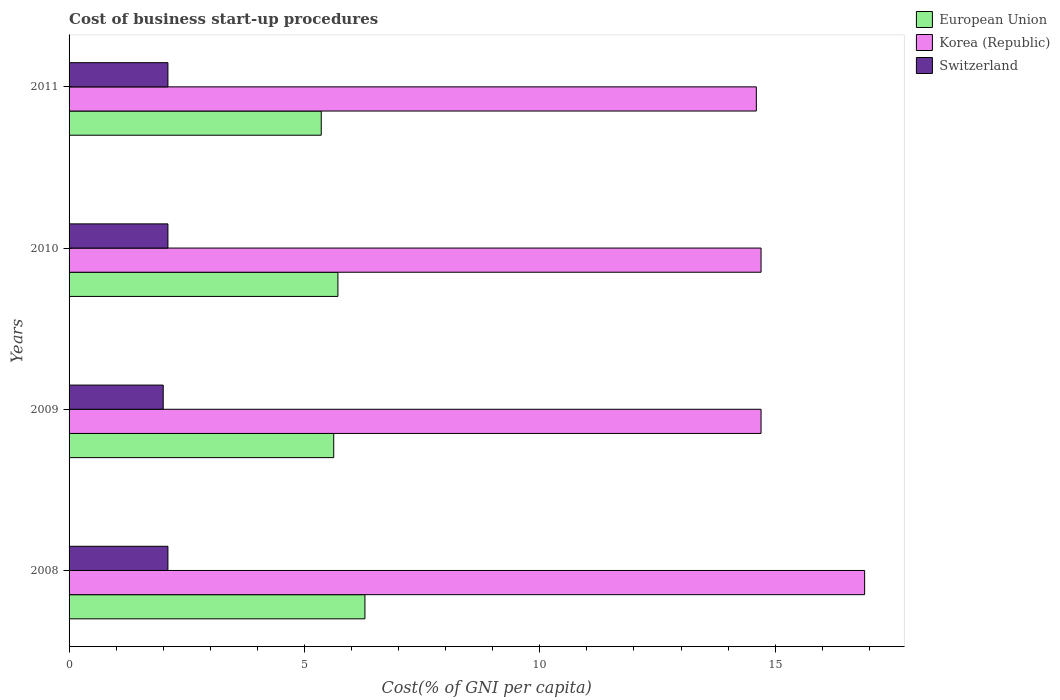How many groups of bars are there?
Your answer should be compact. 4. Are the number of bars per tick equal to the number of legend labels?
Make the answer very short. Yes. How many bars are there on the 3rd tick from the top?
Offer a terse response. 3. How many bars are there on the 4th tick from the bottom?
Offer a terse response. 3. What is the label of the 3rd group of bars from the top?
Your response must be concise. 2009. In how many cases, is the number of bars for a given year not equal to the number of legend labels?
Keep it short and to the point. 0. What is the cost of business start-up procedures in Korea (Republic) in 2008?
Your response must be concise. 16.9. Across all years, what is the minimum cost of business start-up procedures in European Union?
Offer a terse response. 5.36. What is the total cost of business start-up procedures in European Union in the graph?
Offer a very short reply. 22.98. What is the difference between the cost of business start-up procedures in European Union in 2008 and that in 2011?
Provide a short and direct response. 0.93. What is the difference between the cost of business start-up procedures in European Union in 2011 and the cost of business start-up procedures in Korea (Republic) in 2008?
Your answer should be compact. -11.54. What is the average cost of business start-up procedures in Korea (Republic) per year?
Offer a terse response. 15.22. In the year 2011, what is the difference between the cost of business start-up procedures in European Union and cost of business start-up procedures in Korea (Republic)?
Provide a short and direct response. -9.24. What is the ratio of the cost of business start-up procedures in Switzerland in 2009 to that in 2010?
Offer a very short reply. 0.95. Is the cost of business start-up procedures in Switzerland in 2008 less than that in 2010?
Your answer should be very brief. No. Is the difference between the cost of business start-up procedures in European Union in 2008 and 2010 greater than the difference between the cost of business start-up procedures in Korea (Republic) in 2008 and 2010?
Your answer should be very brief. No. What is the difference between the highest and the second highest cost of business start-up procedures in Korea (Republic)?
Provide a short and direct response. 2.2. What is the difference between the highest and the lowest cost of business start-up procedures in Switzerland?
Offer a very short reply. 0.1. In how many years, is the cost of business start-up procedures in Korea (Republic) greater than the average cost of business start-up procedures in Korea (Republic) taken over all years?
Make the answer very short. 1. Is the sum of the cost of business start-up procedures in European Union in 2008 and 2011 greater than the maximum cost of business start-up procedures in Switzerland across all years?
Ensure brevity in your answer.  Yes. What does the 2nd bar from the bottom in 2011 represents?
Ensure brevity in your answer.  Korea (Republic). What is the difference between two consecutive major ticks on the X-axis?
Ensure brevity in your answer.  5. Does the graph contain any zero values?
Your answer should be very brief. No. How many legend labels are there?
Keep it short and to the point. 3. How are the legend labels stacked?
Offer a terse response. Vertical. What is the title of the graph?
Keep it short and to the point. Cost of business start-up procedures. Does "Brazil" appear as one of the legend labels in the graph?
Your answer should be very brief. No. What is the label or title of the X-axis?
Offer a terse response. Cost(% of GNI per capita). What is the Cost(% of GNI per capita) in European Union in 2008?
Give a very brief answer. 6.29. What is the Cost(% of GNI per capita) in Korea (Republic) in 2008?
Your answer should be very brief. 16.9. What is the Cost(% of GNI per capita) in European Union in 2009?
Offer a very short reply. 5.62. What is the Cost(% of GNI per capita) in Korea (Republic) in 2009?
Provide a succinct answer. 14.7. What is the Cost(% of GNI per capita) of European Union in 2010?
Your response must be concise. 5.71. What is the Cost(% of GNI per capita) in Switzerland in 2010?
Your response must be concise. 2.1. What is the Cost(% of GNI per capita) of European Union in 2011?
Keep it short and to the point. 5.36. What is the Cost(% of GNI per capita) of Korea (Republic) in 2011?
Your answer should be very brief. 14.6. What is the Cost(% of GNI per capita) in Switzerland in 2011?
Provide a succinct answer. 2.1. Across all years, what is the maximum Cost(% of GNI per capita) of European Union?
Your response must be concise. 6.29. Across all years, what is the maximum Cost(% of GNI per capita) in Korea (Republic)?
Keep it short and to the point. 16.9. Across all years, what is the maximum Cost(% of GNI per capita) of Switzerland?
Your answer should be very brief. 2.1. Across all years, what is the minimum Cost(% of GNI per capita) in European Union?
Keep it short and to the point. 5.36. Across all years, what is the minimum Cost(% of GNI per capita) in Switzerland?
Keep it short and to the point. 2. What is the total Cost(% of GNI per capita) of European Union in the graph?
Your answer should be very brief. 22.98. What is the total Cost(% of GNI per capita) of Korea (Republic) in the graph?
Give a very brief answer. 60.9. What is the total Cost(% of GNI per capita) of Switzerland in the graph?
Ensure brevity in your answer.  8.3. What is the difference between the Cost(% of GNI per capita) in European Union in 2008 and that in 2009?
Provide a succinct answer. 0.66. What is the difference between the Cost(% of GNI per capita) of Korea (Republic) in 2008 and that in 2009?
Offer a terse response. 2.2. What is the difference between the Cost(% of GNI per capita) of Switzerland in 2008 and that in 2009?
Offer a terse response. 0.1. What is the difference between the Cost(% of GNI per capita) of European Union in 2008 and that in 2010?
Your response must be concise. 0.57. What is the difference between the Cost(% of GNI per capita) in European Union in 2008 and that in 2011?
Keep it short and to the point. 0.93. What is the difference between the Cost(% of GNI per capita) of Korea (Republic) in 2008 and that in 2011?
Offer a very short reply. 2.3. What is the difference between the Cost(% of GNI per capita) in European Union in 2009 and that in 2010?
Your response must be concise. -0.09. What is the difference between the Cost(% of GNI per capita) in Korea (Republic) in 2009 and that in 2010?
Offer a terse response. 0. What is the difference between the Cost(% of GNI per capita) of Switzerland in 2009 and that in 2010?
Provide a short and direct response. -0.1. What is the difference between the Cost(% of GNI per capita) of European Union in 2009 and that in 2011?
Keep it short and to the point. 0.27. What is the difference between the Cost(% of GNI per capita) of Korea (Republic) in 2009 and that in 2011?
Your answer should be very brief. 0.1. What is the difference between the Cost(% of GNI per capita) of European Union in 2010 and that in 2011?
Give a very brief answer. 0.35. What is the difference between the Cost(% of GNI per capita) in Switzerland in 2010 and that in 2011?
Keep it short and to the point. 0. What is the difference between the Cost(% of GNI per capita) of European Union in 2008 and the Cost(% of GNI per capita) of Korea (Republic) in 2009?
Offer a terse response. -8.41. What is the difference between the Cost(% of GNI per capita) of European Union in 2008 and the Cost(% of GNI per capita) of Switzerland in 2009?
Ensure brevity in your answer.  4.29. What is the difference between the Cost(% of GNI per capita) of European Union in 2008 and the Cost(% of GNI per capita) of Korea (Republic) in 2010?
Provide a short and direct response. -8.41. What is the difference between the Cost(% of GNI per capita) in European Union in 2008 and the Cost(% of GNI per capita) in Switzerland in 2010?
Provide a short and direct response. 4.19. What is the difference between the Cost(% of GNI per capita) in European Union in 2008 and the Cost(% of GNI per capita) in Korea (Republic) in 2011?
Provide a succinct answer. -8.31. What is the difference between the Cost(% of GNI per capita) in European Union in 2008 and the Cost(% of GNI per capita) in Switzerland in 2011?
Offer a terse response. 4.19. What is the difference between the Cost(% of GNI per capita) of European Union in 2009 and the Cost(% of GNI per capita) of Korea (Republic) in 2010?
Your answer should be compact. -9.08. What is the difference between the Cost(% of GNI per capita) of European Union in 2009 and the Cost(% of GNI per capita) of Switzerland in 2010?
Make the answer very short. 3.52. What is the difference between the Cost(% of GNI per capita) in European Union in 2009 and the Cost(% of GNI per capita) in Korea (Republic) in 2011?
Give a very brief answer. -8.98. What is the difference between the Cost(% of GNI per capita) in European Union in 2009 and the Cost(% of GNI per capita) in Switzerland in 2011?
Keep it short and to the point. 3.52. What is the difference between the Cost(% of GNI per capita) of Korea (Republic) in 2009 and the Cost(% of GNI per capita) of Switzerland in 2011?
Ensure brevity in your answer.  12.6. What is the difference between the Cost(% of GNI per capita) in European Union in 2010 and the Cost(% of GNI per capita) in Korea (Republic) in 2011?
Provide a succinct answer. -8.89. What is the difference between the Cost(% of GNI per capita) of European Union in 2010 and the Cost(% of GNI per capita) of Switzerland in 2011?
Keep it short and to the point. 3.61. What is the difference between the Cost(% of GNI per capita) of Korea (Republic) in 2010 and the Cost(% of GNI per capita) of Switzerland in 2011?
Provide a succinct answer. 12.6. What is the average Cost(% of GNI per capita) of European Union per year?
Make the answer very short. 5.74. What is the average Cost(% of GNI per capita) in Korea (Republic) per year?
Provide a succinct answer. 15.22. What is the average Cost(% of GNI per capita) in Switzerland per year?
Your response must be concise. 2.08. In the year 2008, what is the difference between the Cost(% of GNI per capita) of European Union and Cost(% of GNI per capita) of Korea (Republic)?
Provide a short and direct response. -10.61. In the year 2008, what is the difference between the Cost(% of GNI per capita) of European Union and Cost(% of GNI per capita) of Switzerland?
Ensure brevity in your answer.  4.19. In the year 2008, what is the difference between the Cost(% of GNI per capita) in Korea (Republic) and Cost(% of GNI per capita) in Switzerland?
Your response must be concise. 14.8. In the year 2009, what is the difference between the Cost(% of GNI per capita) in European Union and Cost(% of GNI per capita) in Korea (Republic)?
Your response must be concise. -9.08. In the year 2009, what is the difference between the Cost(% of GNI per capita) in European Union and Cost(% of GNI per capita) in Switzerland?
Your response must be concise. 3.62. In the year 2010, what is the difference between the Cost(% of GNI per capita) in European Union and Cost(% of GNI per capita) in Korea (Republic)?
Offer a terse response. -8.99. In the year 2010, what is the difference between the Cost(% of GNI per capita) of European Union and Cost(% of GNI per capita) of Switzerland?
Offer a very short reply. 3.61. In the year 2010, what is the difference between the Cost(% of GNI per capita) in Korea (Republic) and Cost(% of GNI per capita) in Switzerland?
Ensure brevity in your answer.  12.6. In the year 2011, what is the difference between the Cost(% of GNI per capita) in European Union and Cost(% of GNI per capita) in Korea (Republic)?
Offer a very short reply. -9.24. In the year 2011, what is the difference between the Cost(% of GNI per capita) of European Union and Cost(% of GNI per capita) of Switzerland?
Provide a short and direct response. 3.26. In the year 2011, what is the difference between the Cost(% of GNI per capita) of Korea (Republic) and Cost(% of GNI per capita) of Switzerland?
Offer a terse response. 12.5. What is the ratio of the Cost(% of GNI per capita) of European Union in 2008 to that in 2009?
Provide a succinct answer. 1.12. What is the ratio of the Cost(% of GNI per capita) in Korea (Republic) in 2008 to that in 2009?
Your response must be concise. 1.15. What is the ratio of the Cost(% of GNI per capita) of Switzerland in 2008 to that in 2009?
Make the answer very short. 1.05. What is the ratio of the Cost(% of GNI per capita) in European Union in 2008 to that in 2010?
Your answer should be very brief. 1.1. What is the ratio of the Cost(% of GNI per capita) of Korea (Republic) in 2008 to that in 2010?
Offer a terse response. 1.15. What is the ratio of the Cost(% of GNI per capita) in European Union in 2008 to that in 2011?
Give a very brief answer. 1.17. What is the ratio of the Cost(% of GNI per capita) of Korea (Republic) in 2008 to that in 2011?
Offer a very short reply. 1.16. What is the ratio of the Cost(% of GNI per capita) in Switzerland in 2008 to that in 2011?
Your answer should be compact. 1. What is the ratio of the Cost(% of GNI per capita) in European Union in 2009 to that in 2010?
Make the answer very short. 0.98. What is the ratio of the Cost(% of GNI per capita) in Korea (Republic) in 2009 to that in 2010?
Give a very brief answer. 1. What is the ratio of the Cost(% of GNI per capita) in European Union in 2009 to that in 2011?
Make the answer very short. 1.05. What is the ratio of the Cost(% of GNI per capita) in Korea (Republic) in 2009 to that in 2011?
Provide a short and direct response. 1.01. What is the ratio of the Cost(% of GNI per capita) in Switzerland in 2009 to that in 2011?
Your answer should be compact. 0.95. What is the ratio of the Cost(% of GNI per capita) in European Union in 2010 to that in 2011?
Offer a very short reply. 1.07. What is the ratio of the Cost(% of GNI per capita) in Korea (Republic) in 2010 to that in 2011?
Ensure brevity in your answer.  1.01. What is the difference between the highest and the second highest Cost(% of GNI per capita) in European Union?
Keep it short and to the point. 0.57. What is the difference between the highest and the second highest Cost(% of GNI per capita) in Korea (Republic)?
Ensure brevity in your answer.  2.2. What is the difference between the highest and the second highest Cost(% of GNI per capita) of Switzerland?
Give a very brief answer. 0. What is the difference between the highest and the lowest Cost(% of GNI per capita) of European Union?
Provide a short and direct response. 0.93. What is the difference between the highest and the lowest Cost(% of GNI per capita) of Switzerland?
Your answer should be compact. 0.1. 